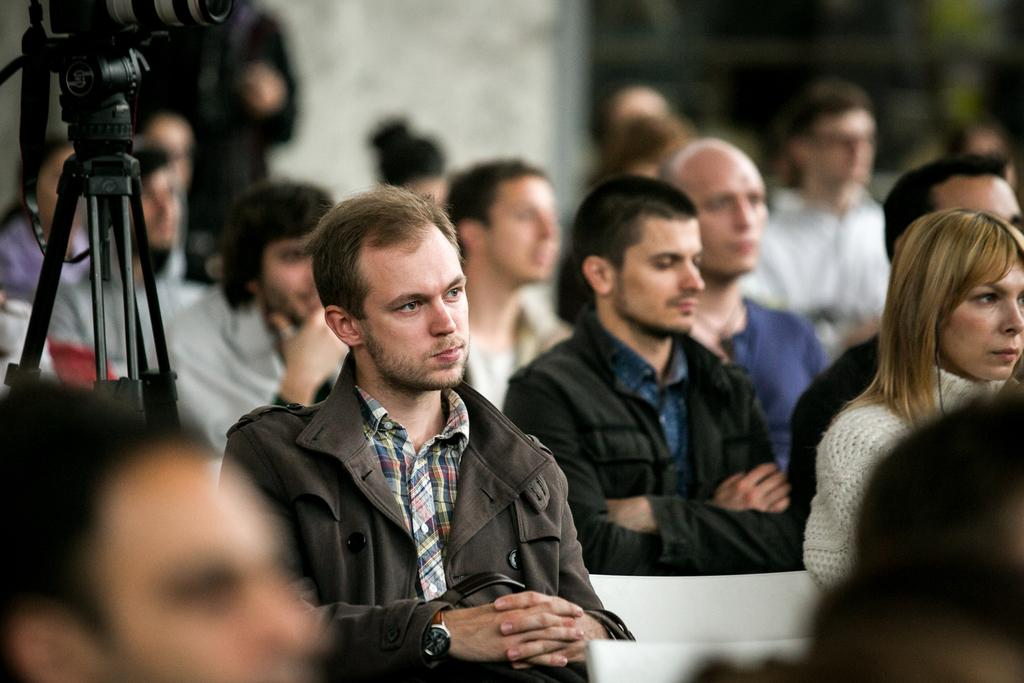What is happening in the image involving a group of people? There is a group of people sitting on chairs in the image. What equipment is present in the image related to photography? There is a camera with a tripod stand in the image. How would you describe the background of the image? The background of the image appears blurry. Can you tell me how many strangers are visible in the image? There is no mention of strangers in the image, so it is not possible to determine their presence or number. 